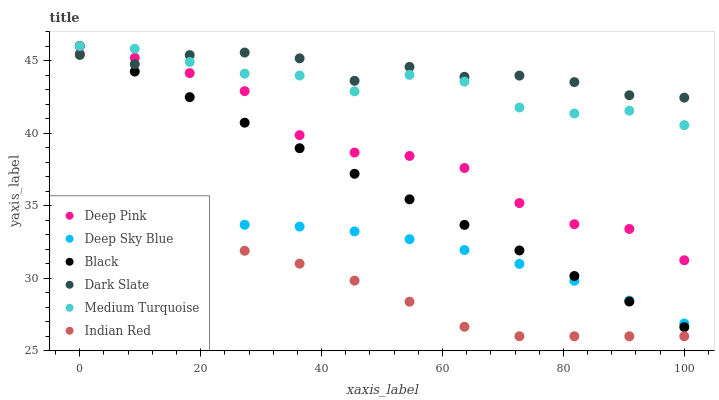Does Indian Red have the minimum area under the curve?
Answer yes or no. Yes. Does Dark Slate have the maximum area under the curve?
Answer yes or no. Yes. Does Medium Turquoise have the minimum area under the curve?
Answer yes or no. No. Does Medium Turquoise have the maximum area under the curve?
Answer yes or no. No. Is Black the smoothest?
Answer yes or no. Yes. Is Deep Pink the roughest?
Answer yes or no. Yes. Is Medium Turquoise the smoothest?
Answer yes or no. No. Is Medium Turquoise the roughest?
Answer yes or no. No. Does Indian Red have the lowest value?
Answer yes or no. Yes. Does Medium Turquoise have the lowest value?
Answer yes or no. No. Does Black have the highest value?
Answer yes or no. Yes. Does Dark Slate have the highest value?
Answer yes or no. No. Is Indian Red less than Dark Slate?
Answer yes or no. Yes. Is Medium Turquoise greater than Deep Sky Blue?
Answer yes or no. Yes. Does Black intersect Deep Pink?
Answer yes or no. Yes. Is Black less than Deep Pink?
Answer yes or no. No. Is Black greater than Deep Pink?
Answer yes or no. No. Does Indian Red intersect Dark Slate?
Answer yes or no. No. 